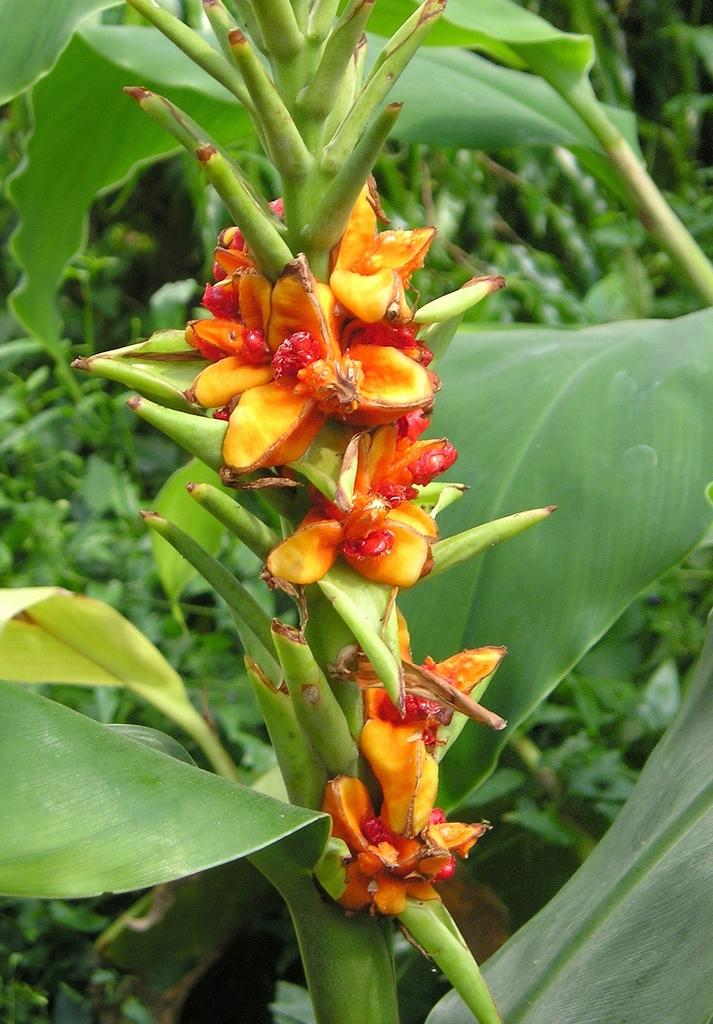What type of plants can be seen in the image? There are flowers in the image. What other parts of plants can be seen in the image? There are leaves in the image. What can be seen in the background of the image? There are trees visible in the background of the image. What type of can is visible in the image? There is no can present in the image; it features flowers, leaves, and trees. How many hens are visible in the image? There are no hens present in the image. 